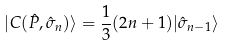Convert formula to latex. <formula><loc_0><loc_0><loc_500><loc_500>| C ( { \hat { P } } , { \hat { \sigma } } _ { n } ) \rangle = \frac { 1 } { 3 } ( 2 n + 1 ) | { \hat { \sigma } } _ { n - 1 } \rangle</formula> 